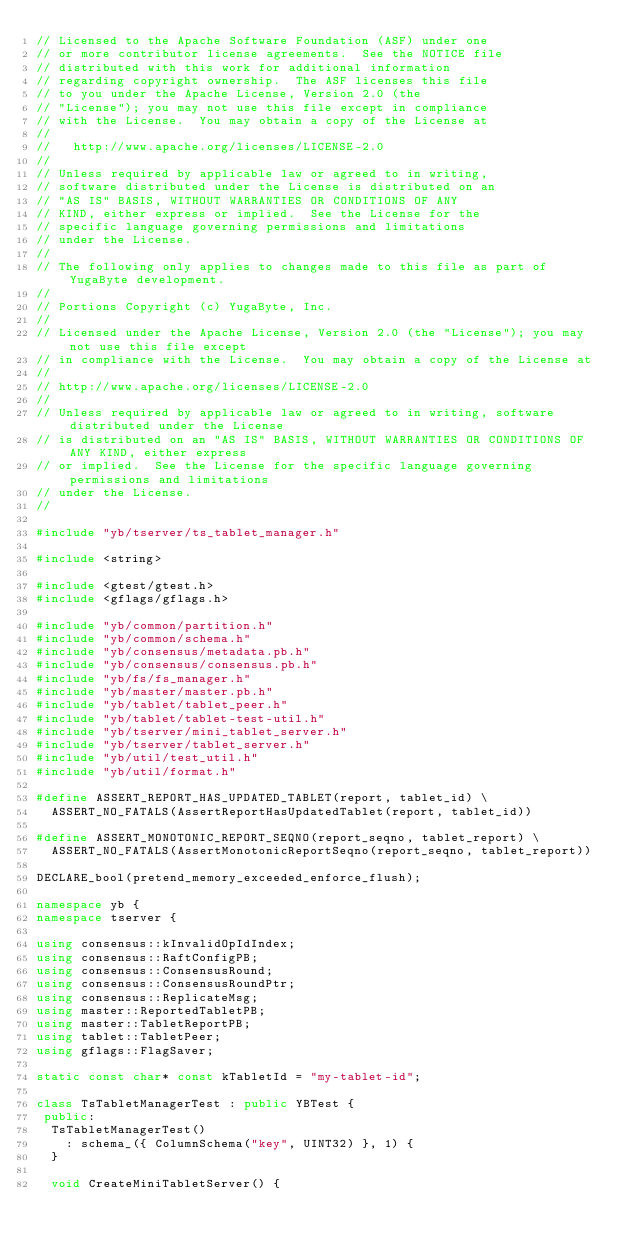<code> <loc_0><loc_0><loc_500><loc_500><_C++_>// Licensed to the Apache Software Foundation (ASF) under one
// or more contributor license agreements.  See the NOTICE file
// distributed with this work for additional information
// regarding copyright ownership.  The ASF licenses this file
// to you under the Apache License, Version 2.0 (the
// "License"); you may not use this file except in compliance
// with the License.  You may obtain a copy of the License at
//
//   http://www.apache.org/licenses/LICENSE-2.0
//
// Unless required by applicable law or agreed to in writing,
// software distributed under the License is distributed on an
// "AS IS" BASIS, WITHOUT WARRANTIES OR CONDITIONS OF ANY
// KIND, either express or implied.  See the License for the
// specific language governing permissions and limitations
// under the License.
//
// The following only applies to changes made to this file as part of YugaByte development.
//
// Portions Copyright (c) YugaByte, Inc.
//
// Licensed under the Apache License, Version 2.0 (the "License"); you may not use this file except
// in compliance with the License.  You may obtain a copy of the License at
//
// http://www.apache.org/licenses/LICENSE-2.0
//
// Unless required by applicable law or agreed to in writing, software distributed under the License
// is distributed on an "AS IS" BASIS, WITHOUT WARRANTIES OR CONDITIONS OF ANY KIND, either express
// or implied.  See the License for the specific language governing permissions and limitations
// under the License.
//

#include "yb/tserver/ts_tablet_manager.h"

#include <string>

#include <gtest/gtest.h>
#include <gflags/gflags.h>

#include "yb/common/partition.h"
#include "yb/common/schema.h"
#include "yb/consensus/metadata.pb.h"
#include "yb/consensus/consensus.pb.h"
#include "yb/fs/fs_manager.h"
#include "yb/master/master.pb.h"
#include "yb/tablet/tablet_peer.h"
#include "yb/tablet/tablet-test-util.h"
#include "yb/tserver/mini_tablet_server.h"
#include "yb/tserver/tablet_server.h"
#include "yb/util/test_util.h"
#include "yb/util/format.h"

#define ASSERT_REPORT_HAS_UPDATED_TABLET(report, tablet_id) \
  ASSERT_NO_FATALS(AssertReportHasUpdatedTablet(report, tablet_id))

#define ASSERT_MONOTONIC_REPORT_SEQNO(report_seqno, tablet_report) \
  ASSERT_NO_FATALS(AssertMonotonicReportSeqno(report_seqno, tablet_report))

DECLARE_bool(pretend_memory_exceeded_enforce_flush);

namespace yb {
namespace tserver {

using consensus::kInvalidOpIdIndex;
using consensus::RaftConfigPB;
using consensus::ConsensusRound;
using consensus::ConsensusRoundPtr;
using consensus::ReplicateMsg;
using master::ReportedTabletPB;
using master::TabletReportPB;
using tablet::TabletPeer;
using gflags::FlagSaver;

static const char* const kTabletId = "my-tablet-id";

class TsTabletManagerTest : public YBTest {
 public:
  TsTabletManagerTest()
    : schema_({ ColumnSchema("key", UINT32) }, 1) {
  }

  void CreateMiniTabletServer() {</code> 